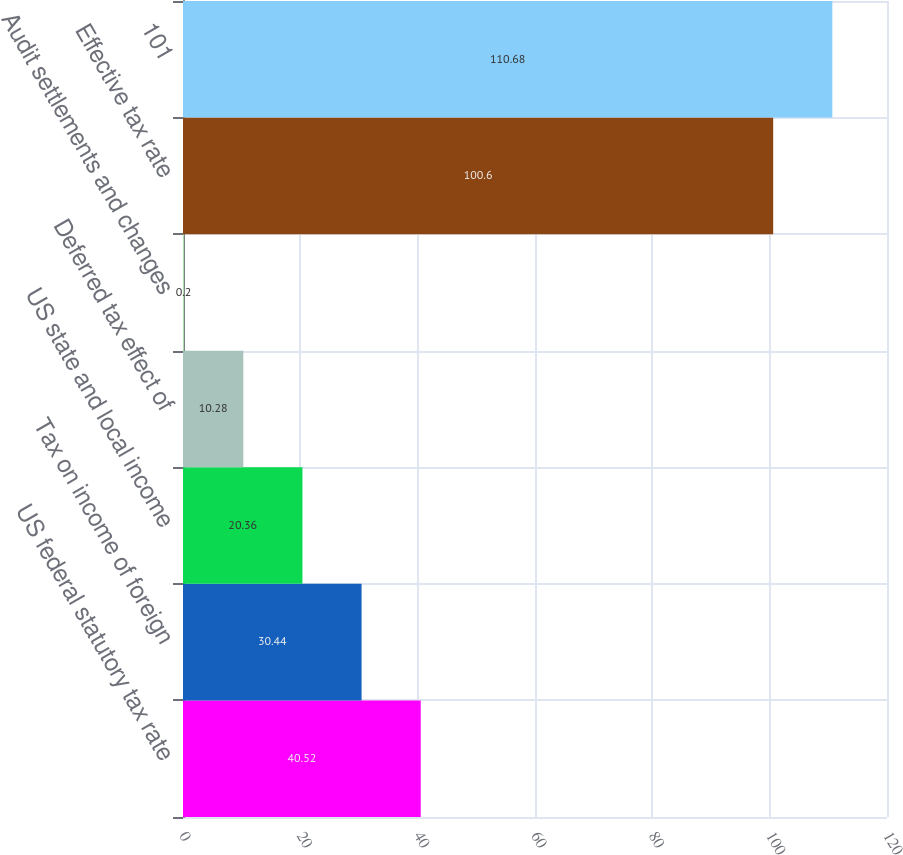<chart> <loc_0><loc_0><loc_500><loc_500><bar_chart><fcel>US federal statutory tax rate<fcel>Tax on income of foreign<fcel>US state and local income<fcel>Deferred tax effect of<fcel>Audit settlements and changes<fcel>Effective tax rate<fcel>101<nl><fcel>40.52<fcel>30.44<fcel>20.36<fcel>10.28<fcel>0.2<fcel>100.6<fcel>110.68<nl></chart> 